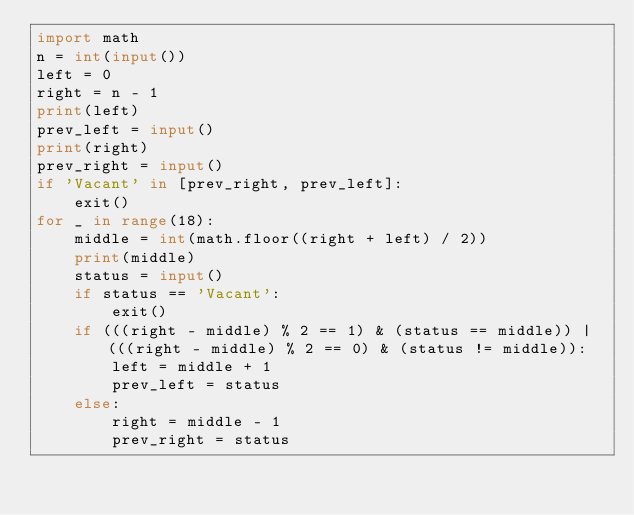Convert code to text. <code><loc_0><loc_0><loc_500><loc_500><_Python_>import math
n = int(input())
left = 0
right = n - 1
print(left)
prev_left = input()
print(right)
prev_right = input()
if 'Vacant' in [prev_right, prev_left]:
    exit()
for _ in range(18):
    middle = int(math.floor((right + left) / 2))
    print(middle)
    status = input()
    if status == 'Vacant':
        exit()
    if (((right - middle) % 2 == 1) & (status == middle)) | (((right - middle) % 2 == 0) & (status != middle)):
        left = middle + 1
        prev_left = status
    else:
        right = middle - 1
        prev_right = status</code> 